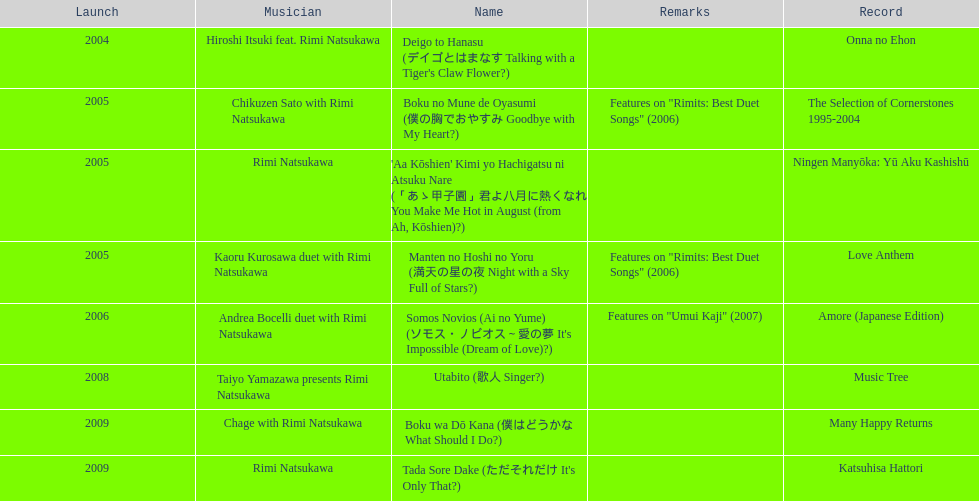Which was released earlier, deigo to hanasu or utabito? Deigo to Hanasu. Could you help me parse every detail presented in this table? {'header': ['Launch', 'Musician', 'Name', 'Remarks', 'Record'], 'rows': [['2004', 'Hiroshi Itsuki feat. Rimi Natsukawa', "Deigo to Hanasu (デイゴとはまなす Talking with a Tiger's Claw Flower?)", '', 'Onna no Ehon'], ['2005', 'Chikuzen Sato with Rimi Natsukawa', 'Boku no Mune de Oyasumi (僕の胸でおやすみ Goodbye with My Heart?)', 'Features on "Rimits: Best Duet Songs" (2006)', 'The Selection of Cornerstones 1995-2004'], ['2005', 'Rimi Natsukawa', "'Aa Kōshien' Kimi yo Hachigatsu ni Atsuku Nare (「あゝ甲子園」君よ八月に熱くなれ You Make Me Hot in August (from Ah, Kōshien)?)", '', 'Ningen Manyōka: Yū Aku Kashishū'], ['2005', 'Kaoru Kurosawa duet with Rimi Natsukawa', 'Manten no Hoshi no Yoru (満天の星の夜 Night with a Sky Full of Stars?)', 'Features on "Rimits: Best Duet Songs" (2006)', 'Love Anthem'], ['2006', 'Andrea Bocelli duet with Rimi Natsukawa', "Somos Novios (Ai no Yume) (ソモス・ノビオス～愛の夢 It's Impossible (Dream of Love)?)", 'Features on "Umui Kaji" (2007)', 'Amore (Japanese Edition)'], ['2008', 'Taiyo Yamazawa presents Rimi Natsukawa', 'Utabito (歌人 Singer?)', '', 'Music Tree'], ['2009', 'Chage with Rimi Natsukawa', 'Boku wa Dō Kana (僕はどうかな What Should I Do?)', '', 'Many Happy Returns'], ['2009', 'Rimi Natsukawa', "Tada Sore Dake (ただそれだけ It's Only That?)", '', 'Katsuhisa Hattori']]} 